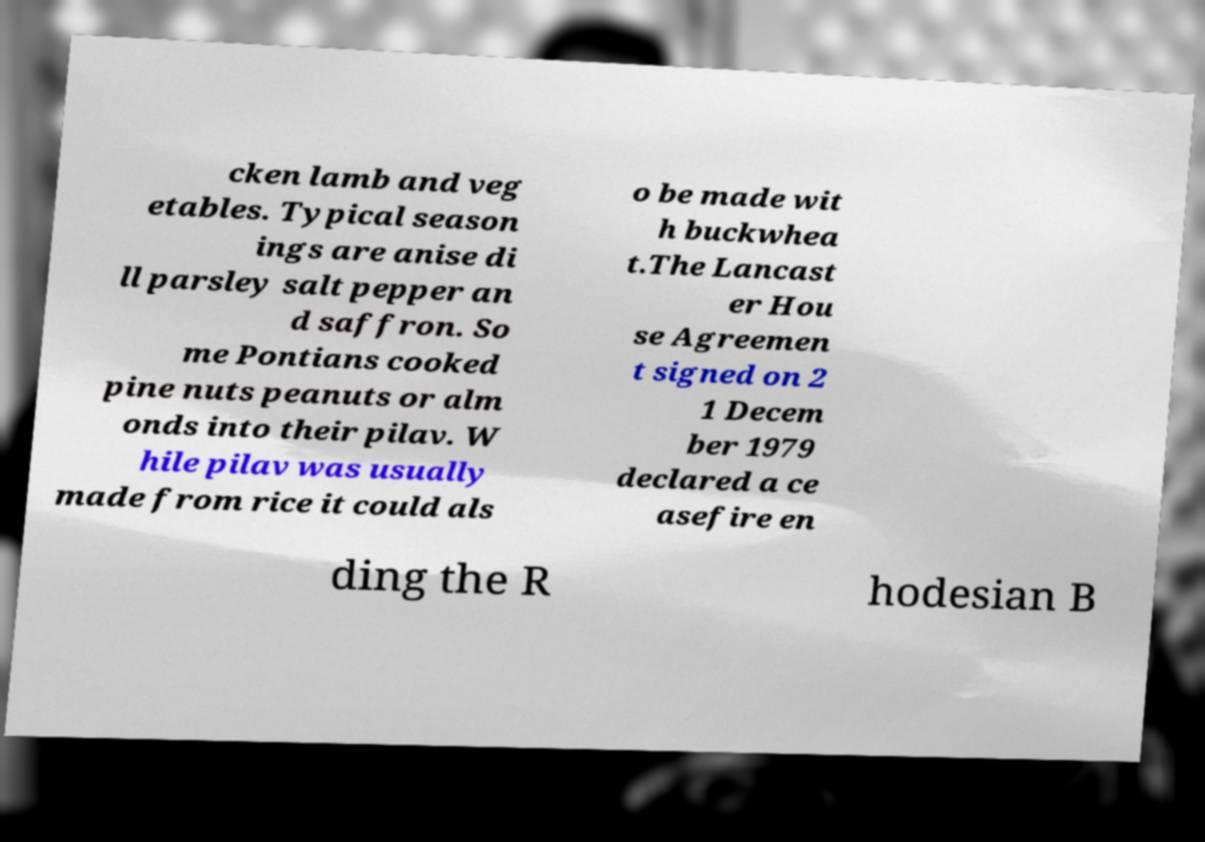Please read and relay the text visible in this image. What does it say? cken lamb and veg etables. Typical season ings are anise di ll parsley salt pepper an d saffron. So me Pontians cooked pine nuts peanuts or alm onds into their pilav. W hile pilav was usually made from rice it could als o be made wit h buckwhea t.The Lancast er Hou se Agreemen t signed on 2 1 Decem ber 1979 declared a ce asefire en ding the R hodesian B 